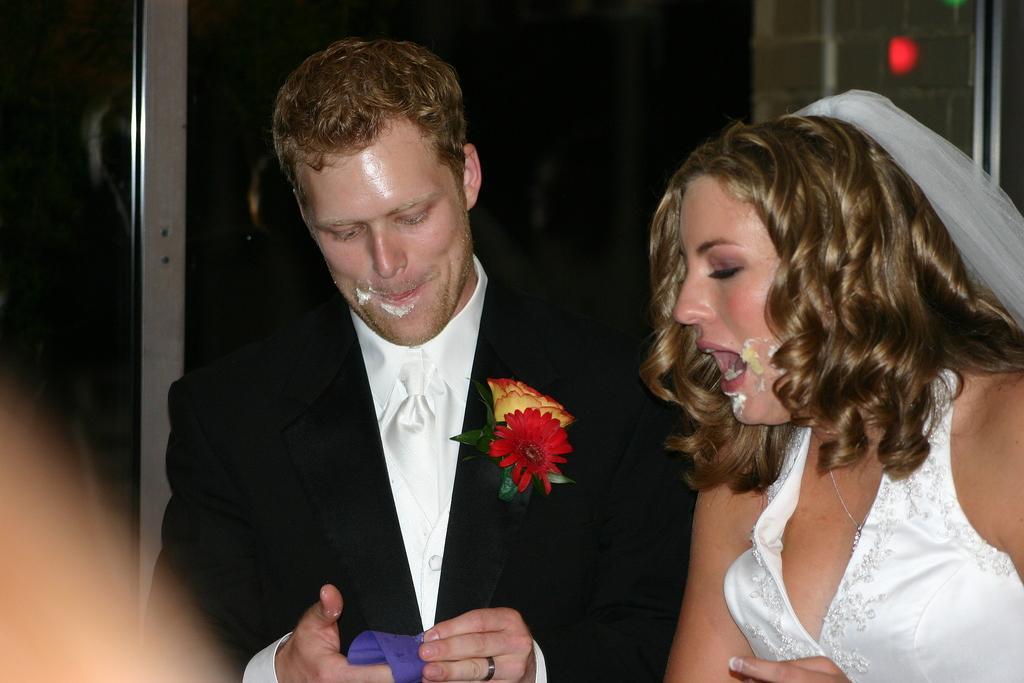Could you give a brief overview of what you see in this image? In the picture I can see a man and a woman are standing. The man is wearing a black color coat and the woman is wearing white color dress. The background of the image is dark. 